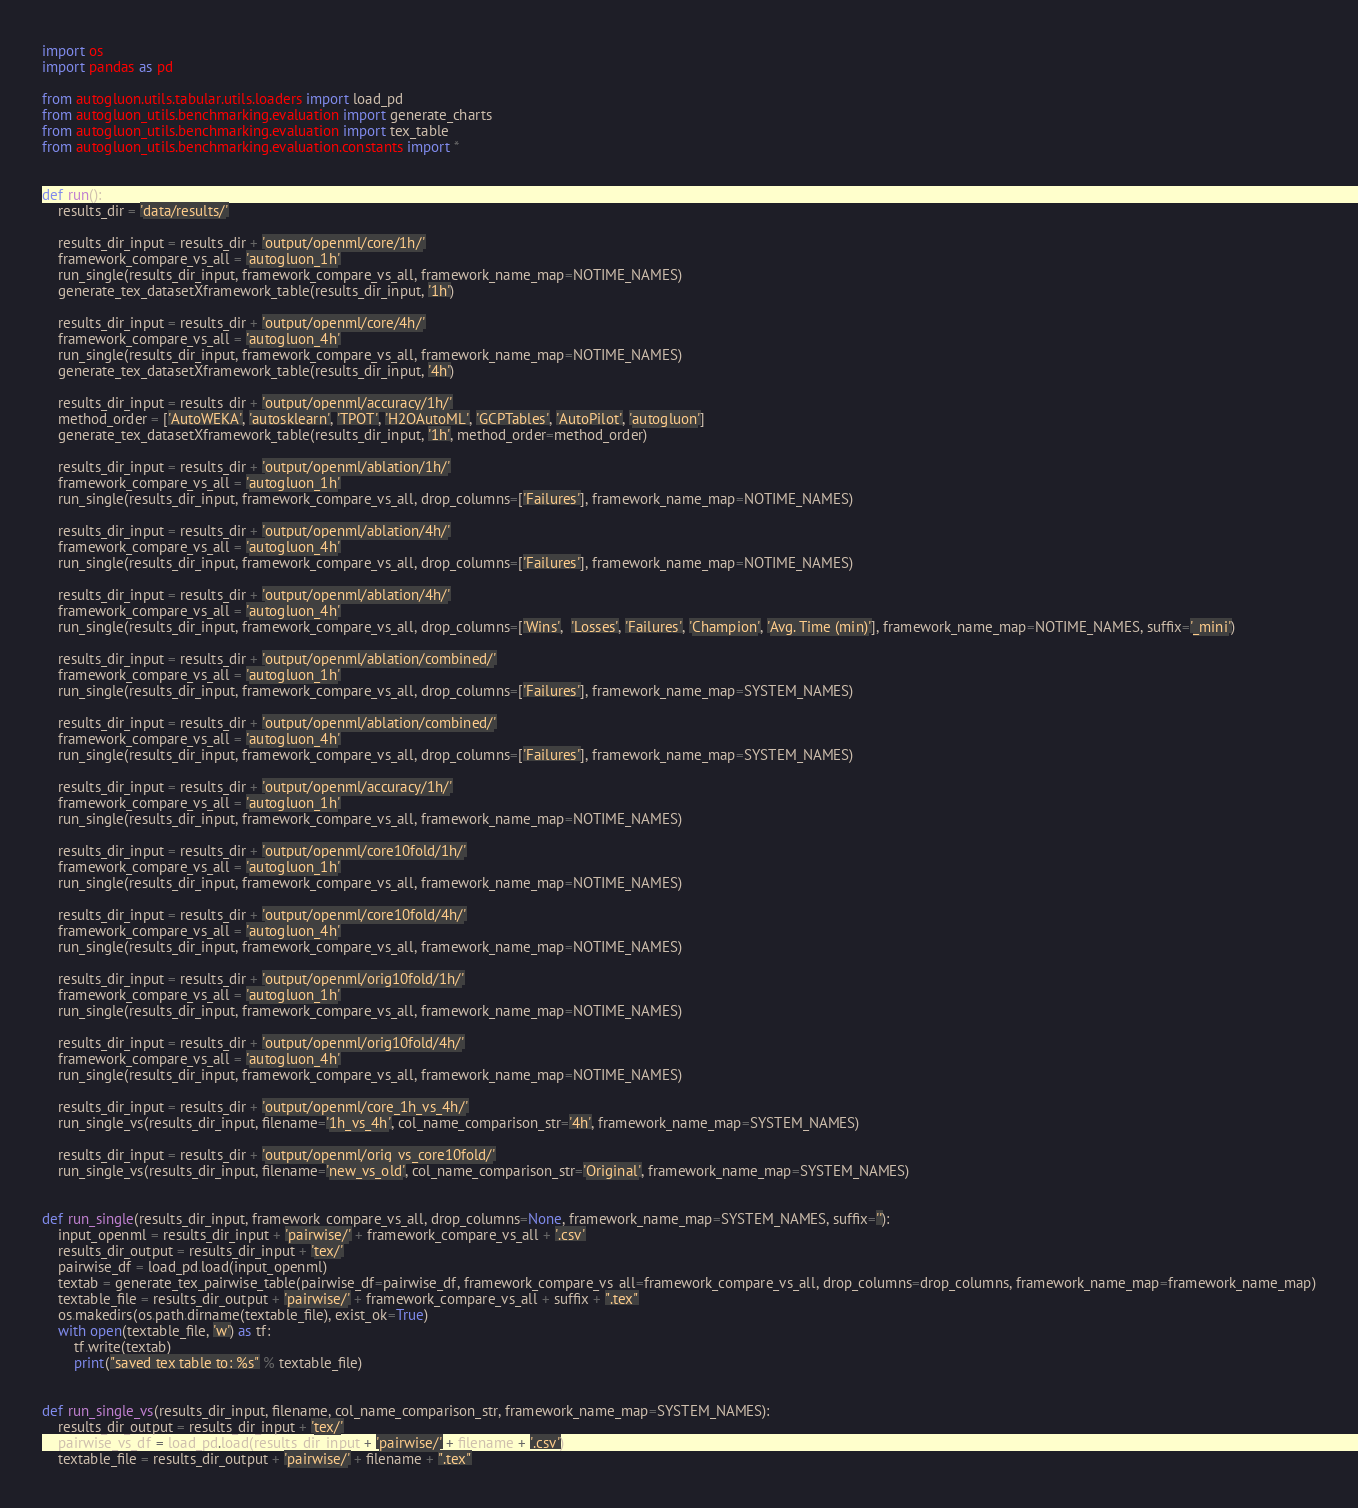Convert code to text. <code><loc_0><loc_0><loc_500><loc_500><_Python_>import os
import pandas as pd

from autogluon.utils.tabular.utils.loaders import load_pd
from autogluon_utils.benchmarking.evaluation import generate_charts
from autogluon_utils.benchmarking.evaluation import tex_table
from autogluon_utils.benchmarking.evaluation.constants import *


def run():
    results_dir = 'data/results/'

    results_dir_input = results_dir + 'output/openml/core/1h/'
    framework_compare_vs_all = 'autogluon_1h'
    run_single(results_dir_input, framework_compare_vs_all, framework_name_map=NOTIME_NAMES)
    generate_tex_datasetXframework_table(results_dir_input, '1h')

    results_dir_input = results_dir + 'output/openml/core/4h/'
    framework_compare_vs_all = 'autogluon_4h'
    run_single(results_dir_input, framework_compare_vs_all, framework_name_map=NOTIME_NAMES)
    generate_tex_datasetXframework_table(results_dir_input, '4h')

    results_dir_input = results_dir + 'output/openml/accuracy/1h/'
    method_order = ['AutoWEKA', 'autosklearn', 'TPOT', 'H2OAutoML', 'GCPTables', 'AutoPilot', 'autogluon']
    generate_tex_datasetXframework_table(results_dir_input, '1h', method_order=method_order)

    results_dir_input = results_dir + 'output/openml/ablation/1h/'
    framework_compare_vs_all = 'autogluon_1h'
    run_single(results_dir_input, framework_compare_vs_all, drop_columns=['Failures'], framework_name_map=NOTIME_NAMES)

    results_dir_input = results_dir + 'output/openml/ablation/4h/'
    framework_compare_vs_all = 'autogluon_4h'
    run_single(results_dir_input, framework_compare_vs_all, drop_columns=['Failures'], framework_name_map=NOTIME_NAMES)

    results_dir_input = results_dir + 'output/openml/ablation/4h/'
    framework_compare_vs_all = 'autogluon_4h'
    run_single(results_dir_input, framework_compare_vs_all, drop_columns=['Wins',  'Losses', 'Failures', 'Champion', 'Avg. Time (min)'], framework_name_map=NOTIME_NAMES, suffix='_mini')

    results_dir_input = results_dir + 'output/openml/ablation/combined/'
    framework_compare_vs_all = 'autogluon_1h'
    run_single(results_dir_input, framework_compare_vs_all, drop_columns=['Failures'], framework_name_map=SYSTEM_NAMES)

    results_dir_input = results_dir + 'output/openml/ablation/combined/'
    framework_compare_vs_all = 'autogluon_4h'
    run_single(results_dir_input, framework_compare_vs_all, drop_columns=['Failures'], framework_name_map=SYSTEM_NAMES)

    results_dir_input = results_dir + 'output/openml/accuracy/1h/'
    framework_compare_vs_all = 'autogluon_1h'
    run_single(results_dir_input, framework_compare_vs_all, framework_name_map=NOTIME_NAMES)

    results_dir_input = results_dir + 'output/openml/core10fold/1h/'
    framework_compare_vs_all = 'autogluon_1h'
    run_single(results_dir_input, framework_compare_vs_all, framework_name_map=NOTIME_NAMES)

    results_dir_input = results_dir + 'output/openml/core10fold/4h/'
    framework_compare_vs_all = 'autogluon_4h'
    run_single(results_dir_input, framework_compare_vs_all, framework_name_map=NOTIME_NAMES)

    results_dir_input = results_dir + 'output/openml/orig10fold/1h/'
    framework_compare_vs_all = 'autogluon_1h'
    run_single(results_dir_input, framework_compare_vs_all, framework_name_map=NOTIME_NAMES)

    results_dir_input = results_dir + 'output/openml/orig10fold/4h/'
    framework_compare_vs_all = 'autogluon_4h'
    run_single(results_dir_input, framework_compare_vs_all, framework_name_map=NOTIME_NAMES)

    results_dir_input = results_dir + 'output/openml/core_1h_vs_4h/'
    run_single_vs(results_dir_input, filename='1h_vs_4h', col_name_comparison_str='4h', framework_name_map=SYSTEM_NAMES)

    results_dir_input = results_dir + 'output/openml/orig_vs_core10fold/'
    run_single_vs(results_dir_input, filename='new_vs_old', col_name_comparison_str='Original', framework_name_map=SYSTEM_NAMES)


def run_single(results_dir_input, framework_compare_vs_all, drop_columns=None, framework_name_map=SYSTEM_NAMES, suffix=''):
    input_openml = results_dir_input + 'pairwise/' + framework_compare_vs_all + '.csv'
    results_dir_output = results_dir_input + 'tex/'
    pairwise_df = load_pd.load(input_openml)
    textab = generate_tex_pairwise_table(pairwise_df=pairwise_df, framework_compare_vs_all=framework_compare_vs_all, drop_columns=drop_columns, framework_name_map=framework_name_map)
    textable_file = results_dir_output + 'pairwise/' + framework_compare_vs_all + suffix + ".tex"
    os.makedirs(os.path.dirname(textable_file), exist_ok=True)
    with open(textable_file, 'w') as tf:
        tf.write(textab)
        print("saved tex table to: %s" % textable_file)


def run_single_vs(results_dir_input, filename, col_name_comparison_str, framework_name_map=SYSTEM_NAMES):
    results_dir_output = results_dir_input + 'tex/'
    pairwise_vs_df = load_pd.load(results_dir_input + 'pairwise/' + filename + '.csv')
    textable_file = results_dir_output + 'pairwise/' + filename + ".tex"</code> 